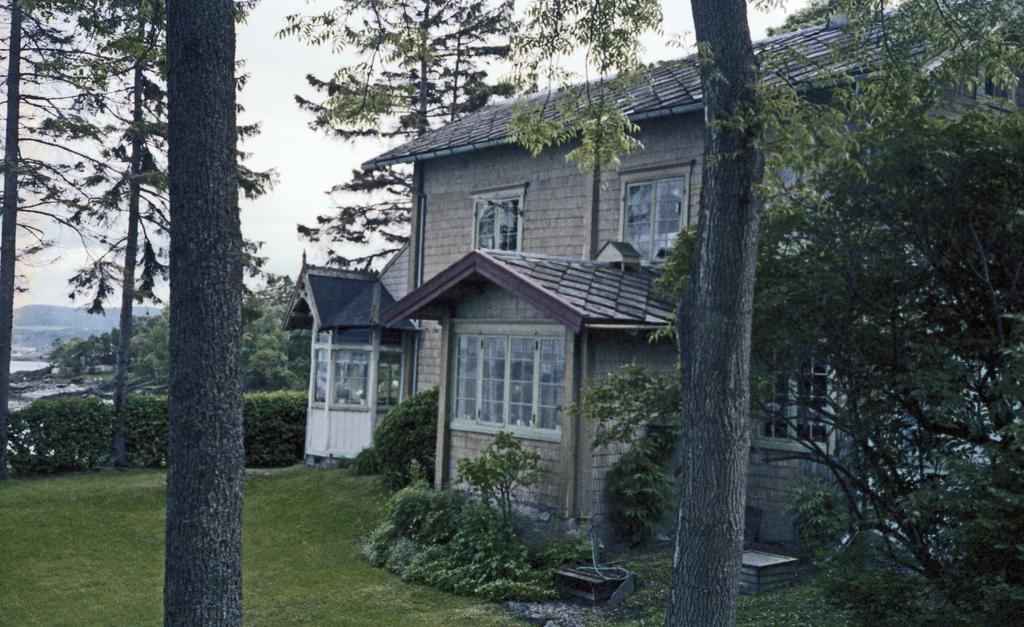What type of vegetation is located at the front of the image? There are trees in the front of the image. What can be seen in the center of the image? There are plants in the center of the image. What covers the ground in the image? There is grass on the ground. What type of building is present in the image? There is a house in the image. Are there any other trees visible in the image? Yes, there are trees in the image. How would you describe the sky in the image? The sky is cloudy in the image. What natural feature can be seen in the image? There is water visible in the image. What type of leather is being used to construct the industrial structure in the image? There is no industrial structure or leather present in the image. What type of industry can be seen in the image? There is no industry present in the image; it features trees, plants, grass, a house, and water. 